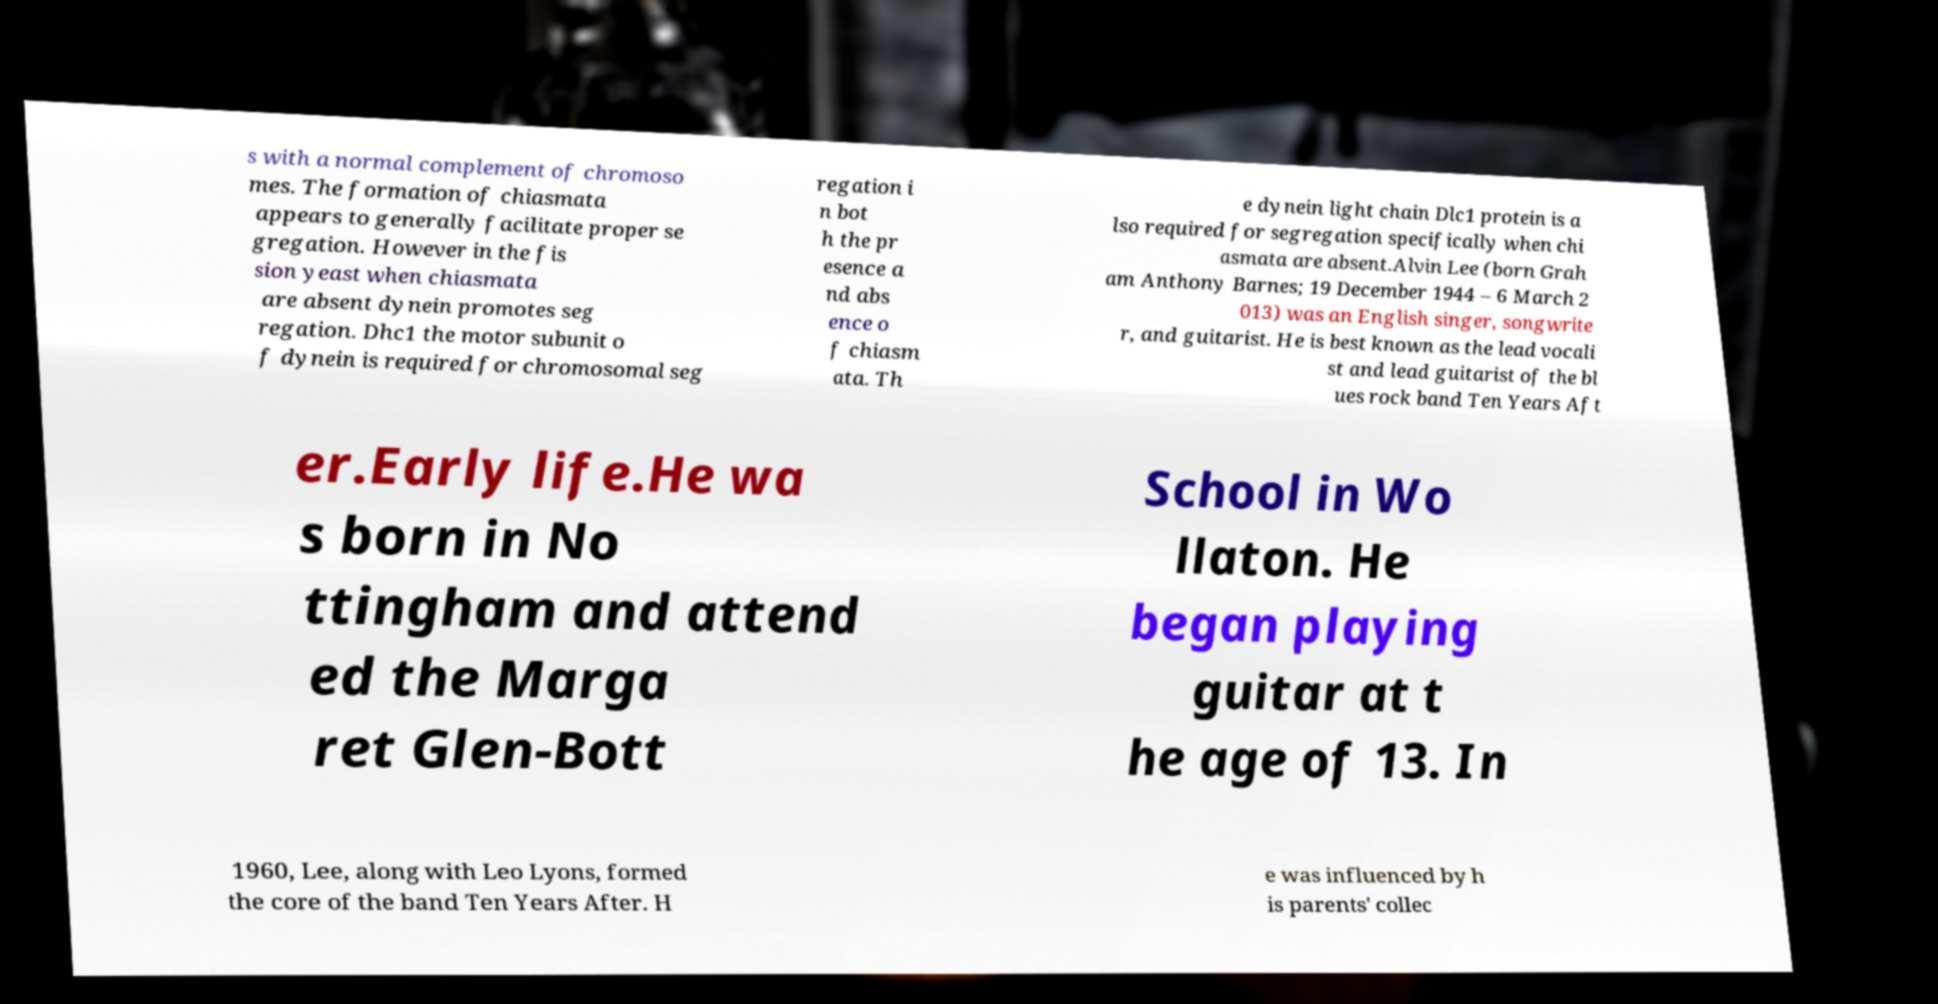Could you assist in decoding the text presented in this image and type it out clearly? s with a normal complement of chromoso mes. The formation of chiasmata appears to generally facilitate proper se gregation. However in the fis sion yeast when chiasmata are absent dynein promotes seg regation. Dhc1 the motor subunit o f dynein is required for chromosomal seg regation i n bot h the pr esence a nd abs ence o f chiasm ata. Th e dynein light chain Dlc1 protein is a lso required for segregation specifically when chi asmata are absent.Alvin Lee (born Grah am Anthony Barnes; 19 December 1944 – 6 March 2 013) was an English singer, songwrite r, and guitarist. He is best known as the lead vocali st and lead guitarist of the bl ues rock band Ten Years Aft er.Early life.He wa s born in No ttingham and attend ed the Marga ret Glen-Bott School in Wo llaton. He began playing guitar at t he age of 13. In 1960, Lee, along with Leo Lyons, formed the core of the band Ten Years After. H e was influenced by h is parents' collec 